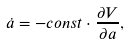Convert formula to latex. <formula><loc_0><loc_0><loc_500><loc_500>\dot { a } = - c o n s t \cdot \frac { \partial V } { \partial a } ,</formula> 